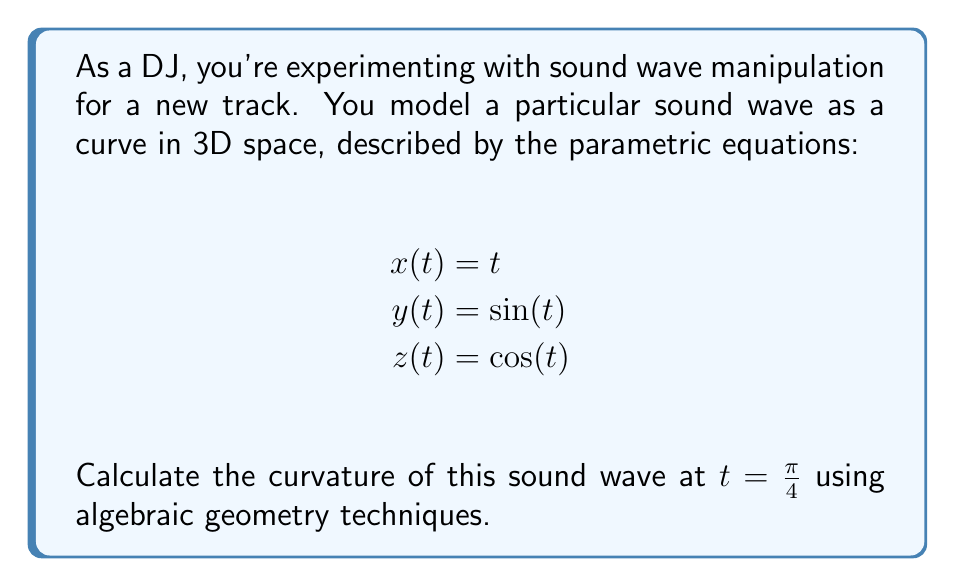Could you help me with this problem? To calculate the curvature of the sound wave, we'll follow these steps:

1) The curvature $\kappa$ of a parametric curve is given by:

   $$\kappa = \frac{|\mathbf{r}'(t) \times \mathbf{r}''(t)|}{|\mathbf{r}'(t)|^3}$$

   where $\mathbf{r}(t) = (x(t), y(t), z(t))$ is the position vector.

2) Let's calculate $\mathbf{r}'(t)$ and $\mathbf{r}''(t)$:

   $\mathbf{r}'(t) = (1, \cos(t), -\sin(t))$
   $\mathbf{r}''(t) = (0, -\sin(t), -\cos(t))$

3) Now, let's compute $\mathbf{r}'(t) \times \mathbf{r}''(t)$:

   $$\mathbf{r}'(t) \times \mathbf{r}''(t) = \begin{vmatrix} 
   \mathbf{i} & \mathbf{j} & \mathbf{k} \\
   1 & \cos(t) & -\sin(t) \\
   0 & -\sin(t) & -\cos(t)
   \end{vmatrix}$$

   $= (-\cos^2(t) - \sin^2(t))\mathbf{i} + (-\sin(t))\mathbf{j} + (\cos(t))\mathbf{k}$

   $= -\mathbf{i} - \sin(t)\mathbf{j} + \cos(t)\mathbf{k}$

4) Calculate the magnitudes:

   $|\mathbf{r}'(t) \times \mathbf{r}''(t)| = \sqrt{1 + \sin^2(t) + \cos^2(t)} = \sqrt{2}$

   $|\mathbf{r}'(t)|^3 = (1 + \cos^2(t) + \sin^2(t))^{3/2} = 2^{3/2}$

5) Therefore, the curvature is:

   $$\kappa = \frac{\sqrt{2}}{2^{3/2}} = \frac{1}{\sqrt{2}}$$

6) This is constant for all $t$, including $t = \frac{\pi}{4}$.
Answer: $\frac{1}{\sqrt{2}}$ 